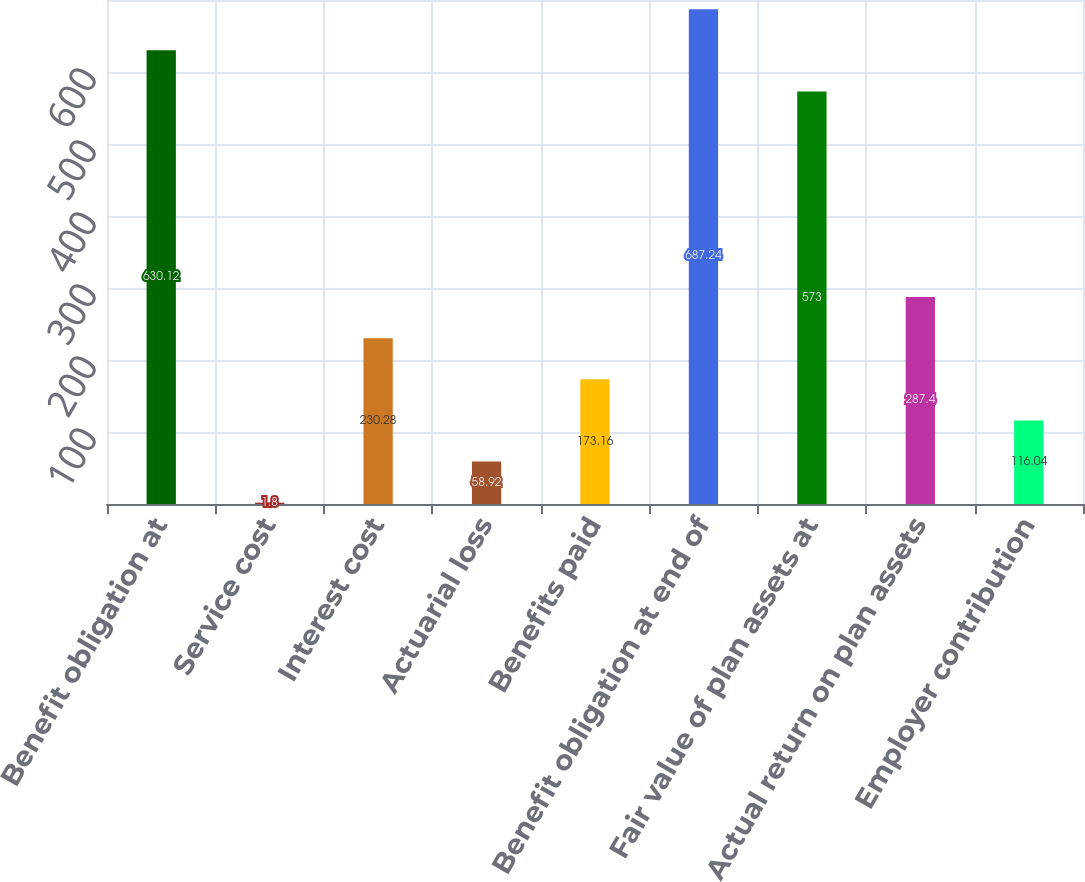<chart> <loc_0><loc_0><loc_500><loc_500><bar_chart><fcel>Benefit obligation at<fcel>Service cost<fcel>Interest cost<fcel>Actuarial loss<fcel>Benefits paid<fcel>Benefit obligation at end of<fcel>Fair value of plan assets at<fcel>Actual return on plan assets<fcel>Employer contribution<nl><fcel>630.12<fcel>1.8<fcel>230.28<fcel>58.92<fcel>173.16<fcel>687.24<fcel>573<fcel>287.4<fcel>116.04<nl></chart> 